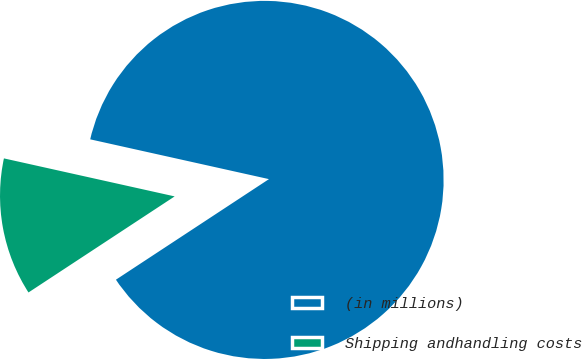Convert chart to OTSL. <chart><loc_0><loc_0><loc_500><loc_500><pie_chart><fcel>(in millions)<fcel>Shipping andhandling costs<nl><fcel>87.26%<fcel>12.74%<nl></chart> 